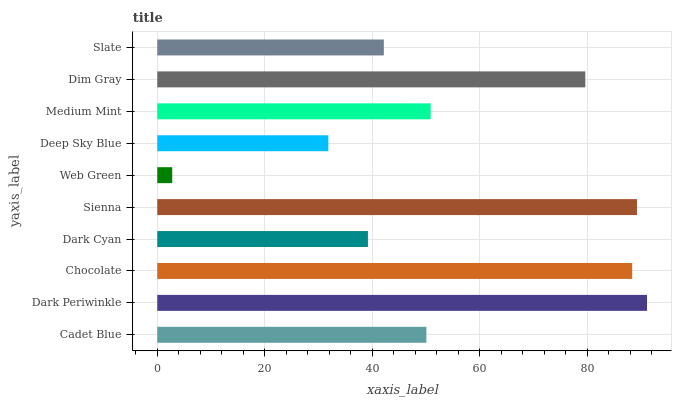Is Web Green the minimum?
Answer yes or no. Yes. Is Dark Periwinkle the maximum?
Answer yes or no. Yes. Is Chocolate the minimum?
Answer yes or no. No. Is Chocolate the maximum?
Answer yes or no. No. Is Dark Periwinkle greater than Chocolate?
Answer yes or no. Yes. Is Chocolate less than Dark Periwinkle?
Answer yes or no. Yes. Is Chocolate greater than Dark Periwinkle?
Answer yes or no. No. Is Dark Periwinkle less than Chocolate?
Answer yes or no. No. Is Medium Mint the high median?
Answer yes or no. Yes. Is Cadet Blue the low median?
Answer yes or no. Yes. Is Dark Periwinkle the high median?
Answer yes or no. No. Is Deep Sky Blue the low median?
Answer yes or no. No. 